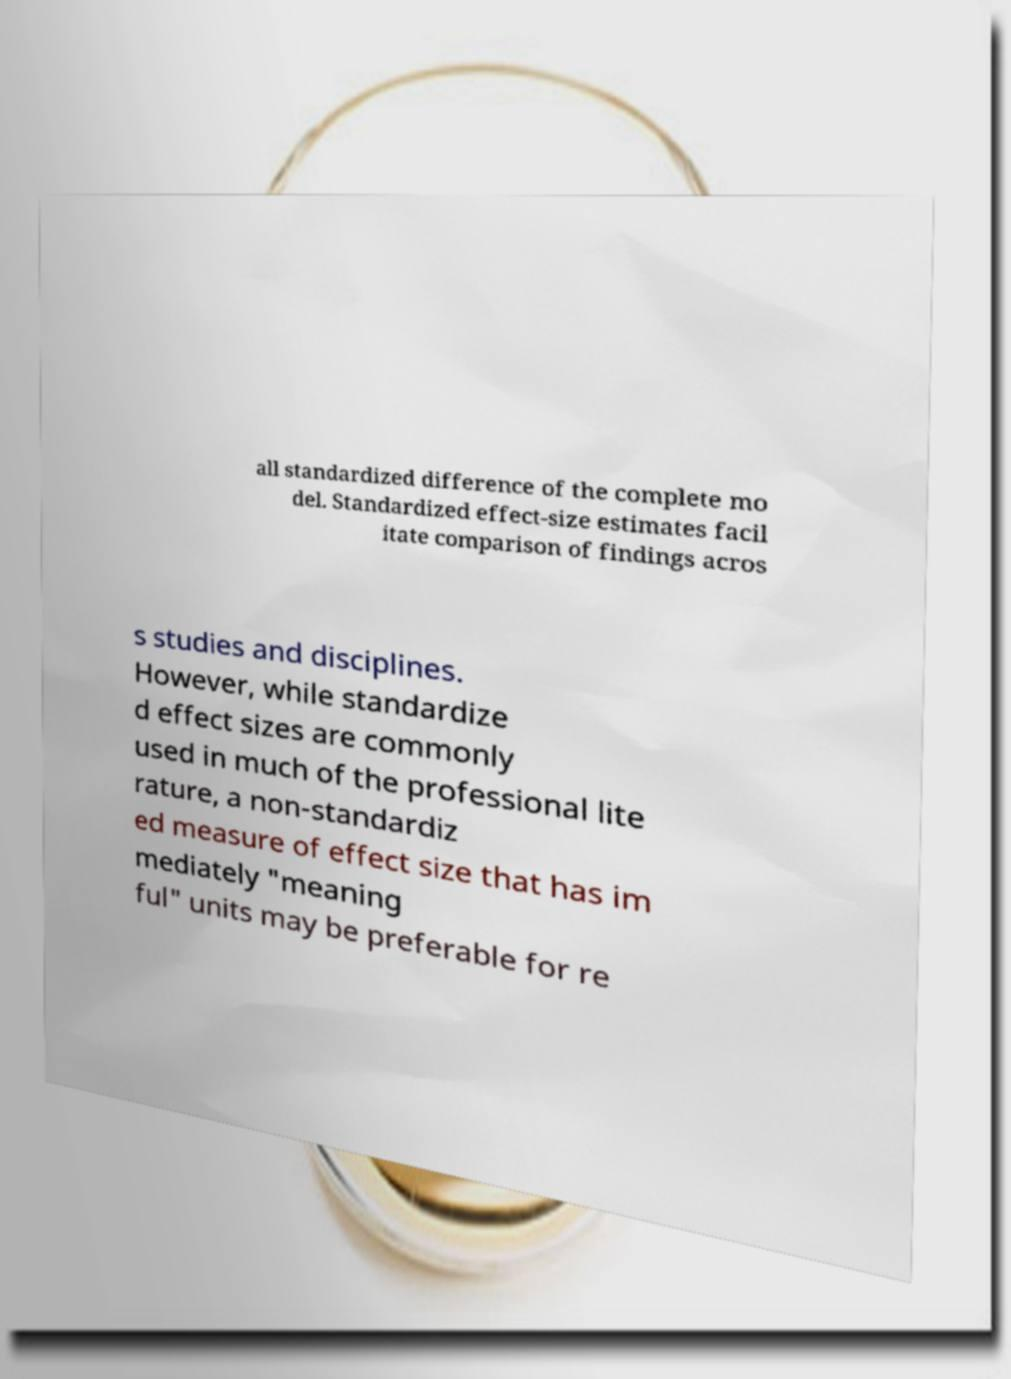Could you assist in decoding the text presented in this image and type it out clearly? all standardized difference of the complete mo del. Standardized effect-size estimates facil itate comparison of findings acros s studies and disciplines. However, while standardize d effect sizes are commonly used in much of the professional lite rature, a non-standardiz ed measure of effect size that has im mediately "meaning ful" units may be preferable for re 